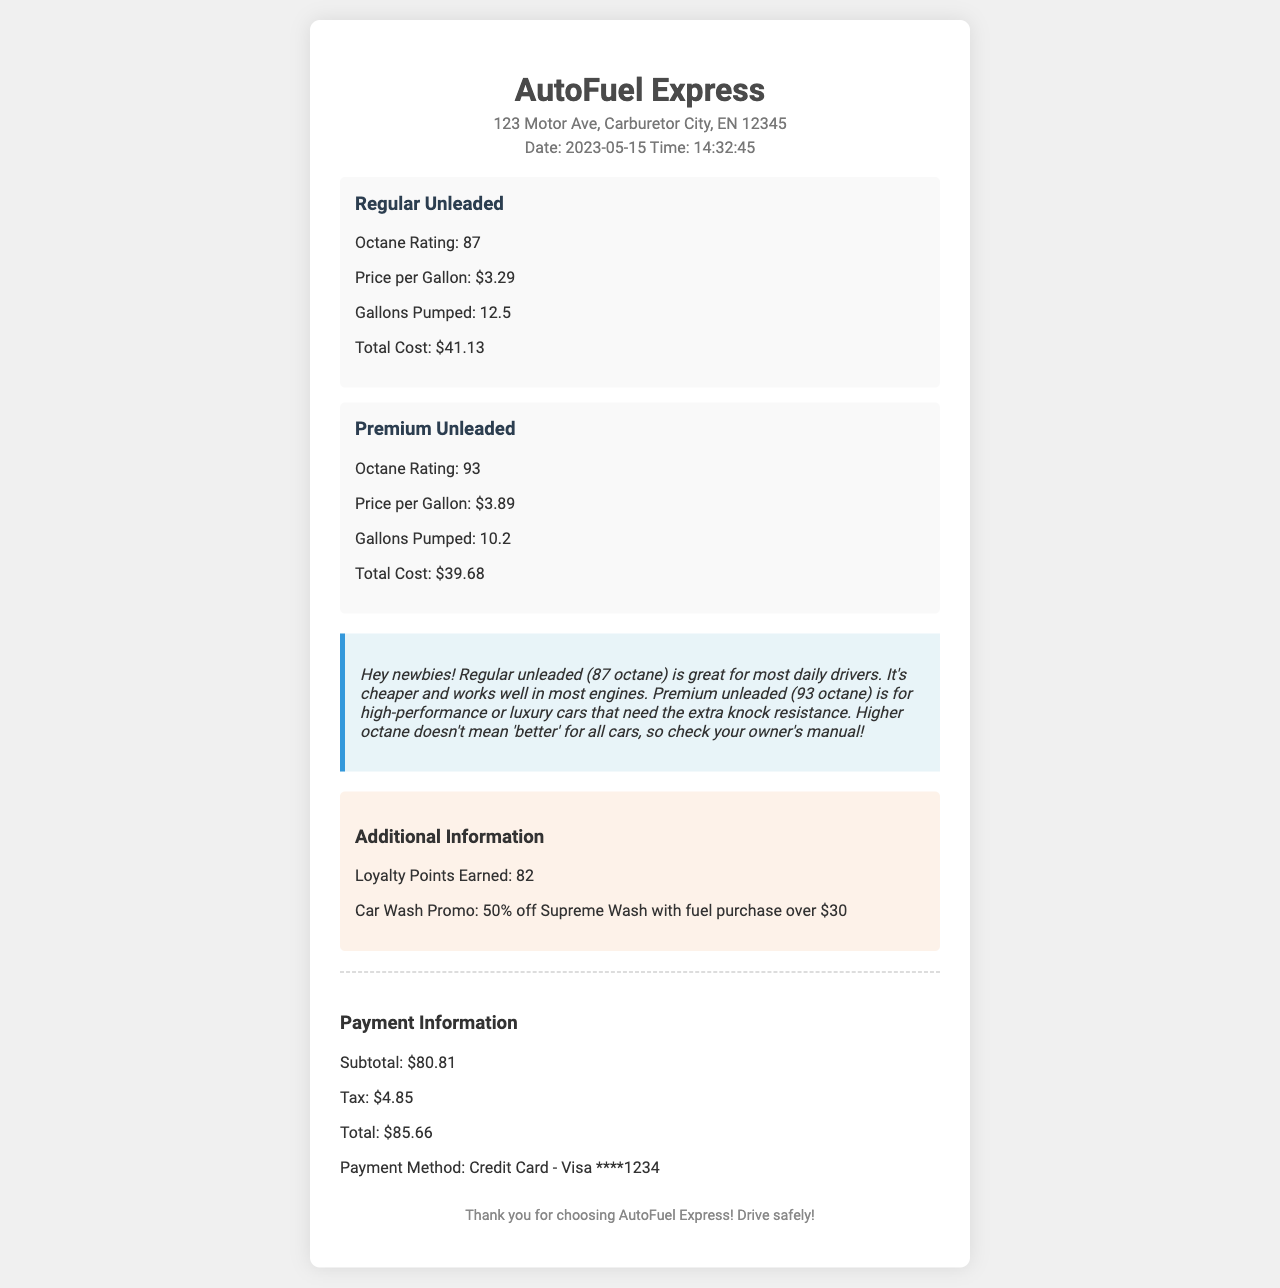What is the name of the gas station? The gas station's name appears at the top of the receipt, which is "AutoFuel Express."
Answer: AutoFuel Express What is the address of the gas station? The address is listed right below the station name on the receipt.
Answer: 123 Motor Ave, Carburetor City, EN 12345 What is the octane rating of Premium Unleaded fuel? Each fuel type includes its octane rating, which is specified in the receipt.
Answer: 93 How much did the customer pay for Regular Unleaded fuel? The total cost for each fuel type is provided on the receipt.
Answer: $41.13 What loyalty points were earned from this purchase? The receipt details any loyalty points earned for the transaction.
Answer: 82 Which promo is associated with the car wash? The receipt includes a promotional offer related to the car wash for customers.
Answer: 50% off Supreme Wash with fuel purchase over $30 What was the payment method used for this transaction? The payment information section specifies how the payment was made.
Answer: Credit Card - Visa ****1234 What is the total cost of the purchase? The total payment amount is calculated and displayed on the receipt.
Answer: $85.66 Why is higher octane better for some cars? The explanation provided in the receipt clarifies why certain cars may require higher octane fuel.
Answer: Extra knock resistance 